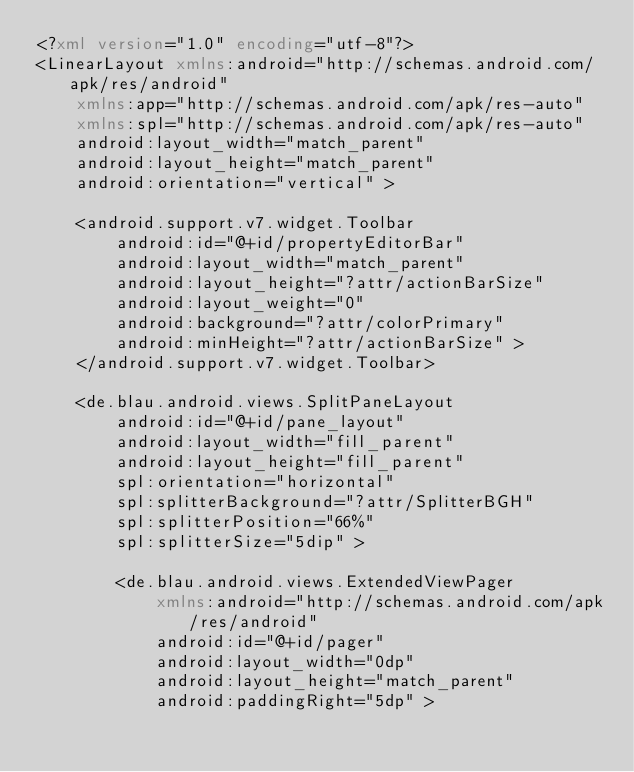<code> <loc_0><loc_0><loc_500><loc_500><_XML_><?xml version="1.0" encoding="utf-8"?>
<LinearLayout xmlns:android="http://schemas.android.com/apk/res/android"
    xmlns:app="http://schemas.android.com/apk/res-auto"
    xmlns:spl="http://schemas.android.com/apk/res-auto"
    android:layout_width="match_parent"
    android:layout_height="match_parent"
    android:orientation="vertical" >

    <android.support.v7.widget.Toolbar
        android:id="@+id/propertyEditorBar"
        android:layout_width="match_parent"
        android:layout_height="?attr/actionBarSize"
        android:layout_weight="0"
        android:background="?attr/colorPrimary"
        android:minHeight="?attr/actionBarSize" >
    </android.support.v7.widget.Toolbar>

    <de.blau.android.views.SplitPaneLayout
        android:id="@+id/pane_layout"
        android:layout_width="fill_parent"
        android:layout_height="fill_parent"
        spl:orientation="horizontal"
        spl:splitterBackground="?attr/SplitterBGH"
        spl:splitterPosition="66%"
        spl:splitterSize="5dip" >

        <de.blau.android.views.ExtendedViewPager
            xmlns:android="http://schemas.android.com/apk/res/android"
            android:id="@+id/pager"
            android:layout_width="0dp"
            android:layout_height="match_parent"
            android:paddingRight="5dp" >
</code> 